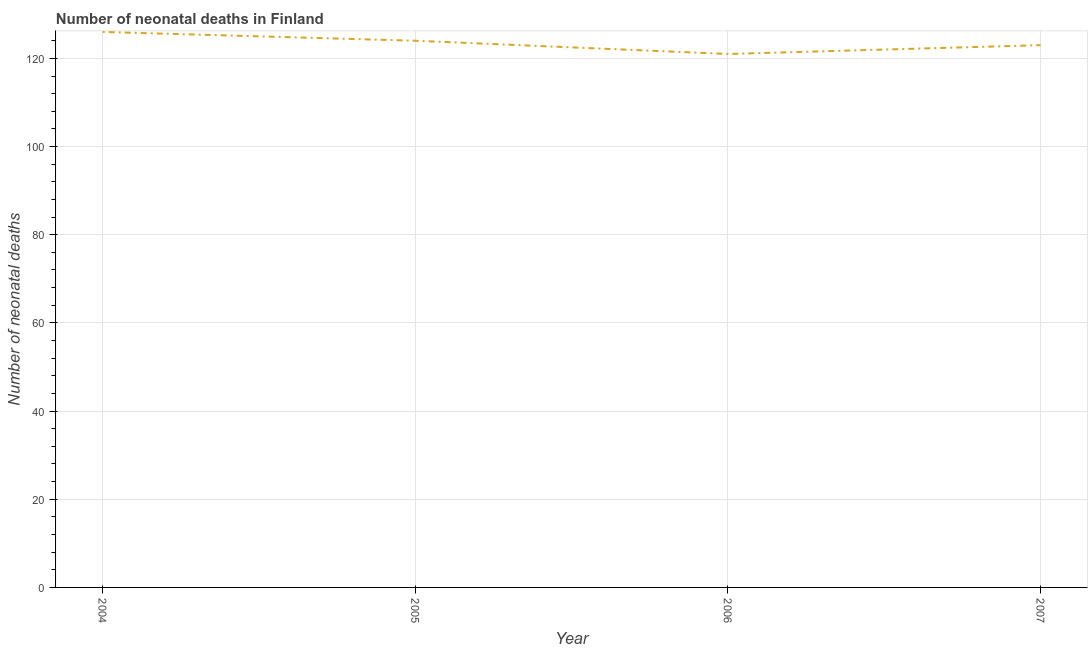What is the number of neonatal deaths in 2004?
Offer a terse response. 126. Across all years, what is the maximum number of neonatal deaths?
Your answer should be compact. 126. Across all years, what is the minimum number of neonatal deaths?
Offer a terse response. 121. What is the sum of the number of neonatal deaths?
Your answer should be compact. 494. What is the difference between the number of neonatal deaths in 2004 and 2005?
Your answer should be very brief. 2. What is the average number of neonatal deaths per year?
Your answer should be compact. 123.5. What is the median number of neonatal deaths?
Your answer should be very brief. 123.5. Do a majority of the years between 2005 and 2007 (inclusive) have number of neonatal deaths greater than 80 ?
Provide a short and direct response. Yes. What is the ratio of the number of neonatal deaths in 2005 to that in 2007?
Offer a very short reply. 1.01. Is the number of neonatal deaths in 2005 less than that in 2006?
Make the answer very short. No. What is the difference between the highest and the lowest number of neonatal deaths?
Your answer should be very brief. 5. In how many years, is the number of neonatal deaths greater than the average number of neonatal deaths taken over all years?
Your response must be concise. 2. Does the number of neonatal deaths monotonically increase over the years?
Keep it short and to the point. No. What is the difference between two consecutive major ticks on the Y-axis?
Your answer should be compact. 20. Are the values on the major ticks of Y-axis written in scientific E-notation?
Keep it short and to the point. No. Does the graph contain grids?
Your answer should be very brief. Yes. What is the title of the graph?
Provide a succinct answer. Number of neonatal deaths in Finland. What is the label or title of the X-axis?
Provide a succinct answer. Year. What is the label or title of the Y-axis?
Your answer should be compact. Number of neonatal deaths. What is the Number of neonatal deaths of 2004?
Make the answer very short. 126. What is the Number of neonatal deaths of 2005?
Ensure brevity in your answer.  124. What is the Number of neonatal deaths in 2006?
Give a very brief answer. 121. What is the Number of neonatal deaths of 2007?
Keep it short and to the point. 123. What is the difference between the Number of neonatal deaths in 2004 and 2005?
Offer a very short reply. 2. What is the difference between the Number of neonatal deaths in 2004 and 2007?
Ensure brevity in your answer.  3. What is the difference between the Number of neonatal deaths in 2005 and 2006?
Ensure brevity in your answer.  3. What is the difference between the Number of neonatal deaths in 2005 and 2007?
Keep it short and to the point. 1. What is the difference between the Number of neonatal deaths in 2006 and 2007?
Provide a succinct answer. -2. What is the ratio of the Number of neonatal deaths in 2004 to that in 2006?
Give a very brief answer. 1.04. What is the ratio of the Number of neonatal deaths in 2005 to that in 2007?
Make the answer very short. 1.01. What is the ratio of the Number of neonatal deaths in 2006 to that in 2007?
Ensure brevity in your answer.  0.98. 